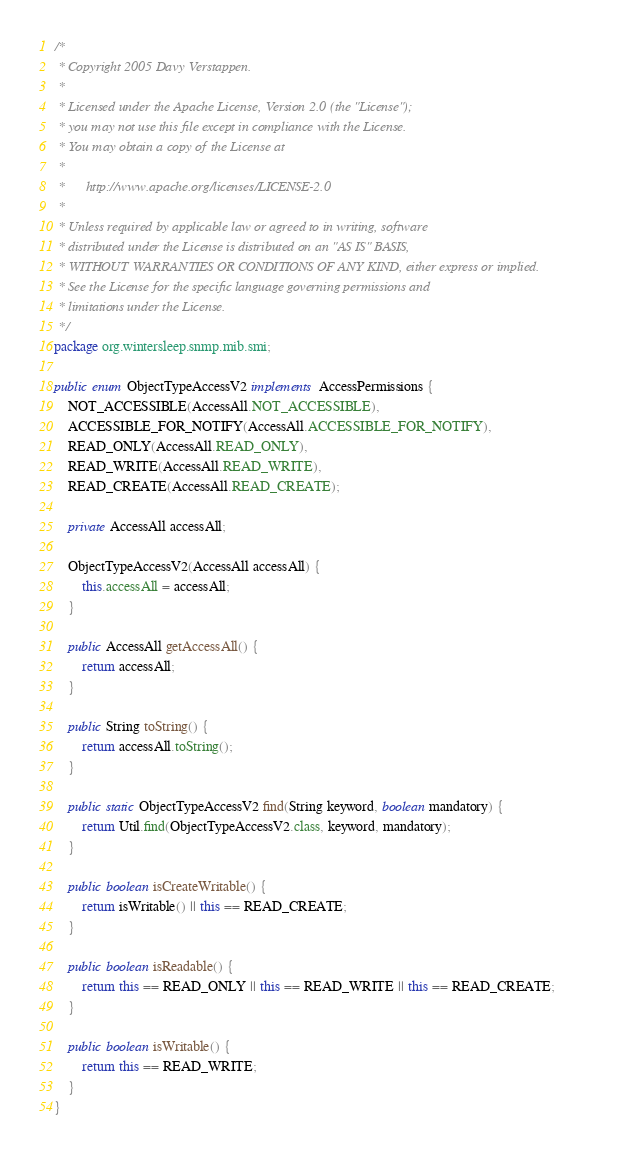<code> <loc_0><loc_0><loc_500><loc_500><_Java_>/*
 * Copyright 2005 Davy Verstappen.
 *
 * Licensed under the Apache License, Version 2.0 (the "License");
 * you may not use this file except in compliance with the License.
 * You may obtain a copy of the License at
 *
 *      http://www.apache.org/licenses/LICENSE-2.0
 *
 * Unless required by applicable law or agreed to in writing, software
 * distributed under the License is distributed on an "AS IS" BASIS,
 * WITHOUT WARRANTIES OR CONDITIONS OF ANY KIND, either express or implied.
 * See the License for the specific language governing permissions and
 * limitations under the License.
 */
package org.wintersleep.snmp.mib.smi;

public enum ObjectTypeAccessV2 implements AccessPermissions {
    NOT_ACCESSIBLE(AccessAll.NOT_ACCESSIBLE),
    ACCESSIBLE_FOR_NOTIFY(AccessAll.ACCESSIBLE_FOR_NOTIFY),
    READ_ONLY(AccessAll.READ_ONLY),
    READ_WRITE(AccessAll.READ_WRITE),
    READ_CREATE(AccessAll.READ_CREATE);

    private AccessAll accessAll;

    ObjectTypeAccessV2(AccessAll accessAll) {
        this.accessAll = accessAll;
    }

    public AccessAll getAccessAll() {
        return accessAll;
    }

    public String toString() {
        return accessAll.toString();
    }

    public static ObjectTypeAccessV2 find(String keyword, boolean mandatory) {
        return Util.find(ObjectTypeAccessV2.class, keyword, mandatory);
    }

    public boolean isCreateWritable() {        
        return isWritable() || this == READ_CREATE;        
    }

    public boolean isReadable() {
        return this == READ_ONLY || this == READ_WRITE || this == READ_CREATE;
    }

    public boolean isWritable() {        
        return this == READ_WRITE;
    }
}
</code> 